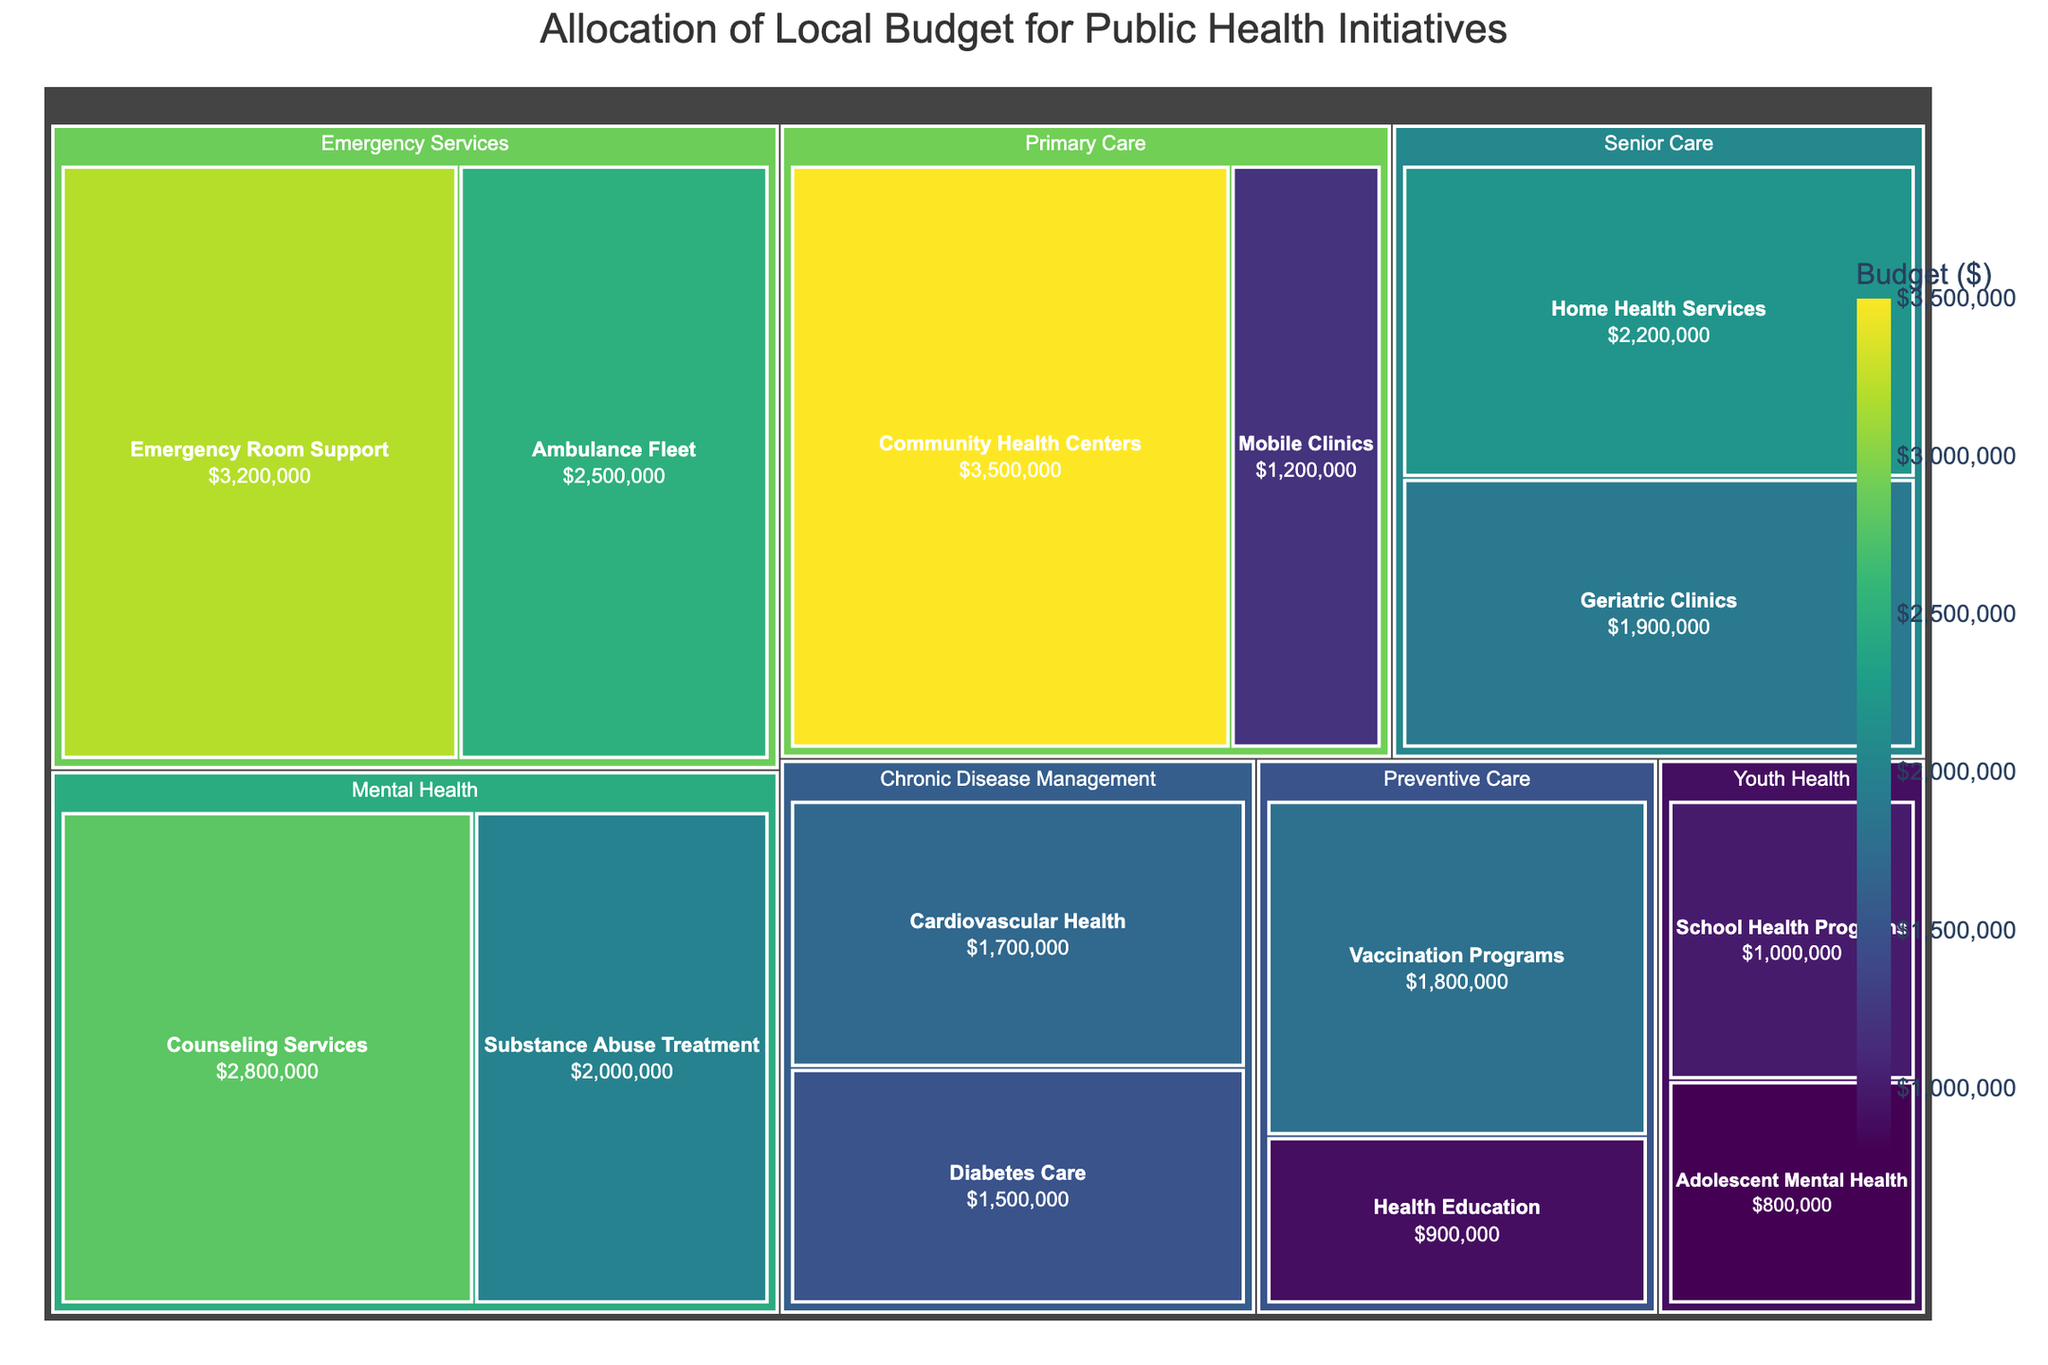What is the title of the treemap? The title is displayed at the top center of the figure and informs the viewer about the main topic of the plot. It reads "Allocation of Local Budget for Public Health Initiatives."
Answer: Allocation of Local Budget for Public Health Initiatives What is the budget allocation for Community Health Centers? Locate the "Primary Care" category, then find the "Community Health Centers" subcategory on the treemap. The value shown for this subcategory is $3,500,000.
Answer: $3,500,000 Which category has the highest total budget allocation? Compare the sizes of the blocks representing each category. The largest block belongs to "Primary Care," indicating it has the highest total budget allocation.
Answer: Primary Care How much more is allocated to Emergency Room Support compared to Adolescent Mental Health? Find the budget for both "Emergency Room Support" ($3,200,000) and "Adolescent Mental Health" ($800,000). Subtract the latter from the former: $3,200,000 - $800,000.
Answer: $2,400,000 What is the combined budget for all subcategories under Mental Health? Add the budget allocations for "Counseling Services" ($2,800,000) and "Substance Abuse Treatment" ($2,000,000). Total: $2,800,000 + $2,000,000.
Answer: $4,800,000 Which has a higher budget, Ambulance Fleet or Geriatric Clinics? Compare the budget allocations for "Ambulance Fleet" ($2,500,000) and "Geriatric Clinics" ($1,900,000). "Ambulance Fleet" has the higher budget.
Answer: Ambulance Fleet What percent of the Primary Care budget is allocated to Mobile Clinics? The total budget for Primary Care is the sum of Community Health Centers ($3,500,000) and Mobile Clinics ($1,200,000), which equals $4,700,000. The percentage is then calculated as ($1,200,000 / $4,700,000) * 100%.
Answer: 25.53% What is the smallest budget allocation on the treemap, and to which subcategory does it belong? Identify the smallest block on the treemap, which corresponds to the budget allocation of $900,000 for "Health Education" under the "Preventive Care" category.
Answer: Health Education What are the total budget allocations for all subcategories under Youth Health? Add the budget allocations for "School Health Programs" ($1,000,000) and "Adolescent Mental Health" ($800,000). The total is $1,000,000 + $800,000.
Answer: $1,800,000 